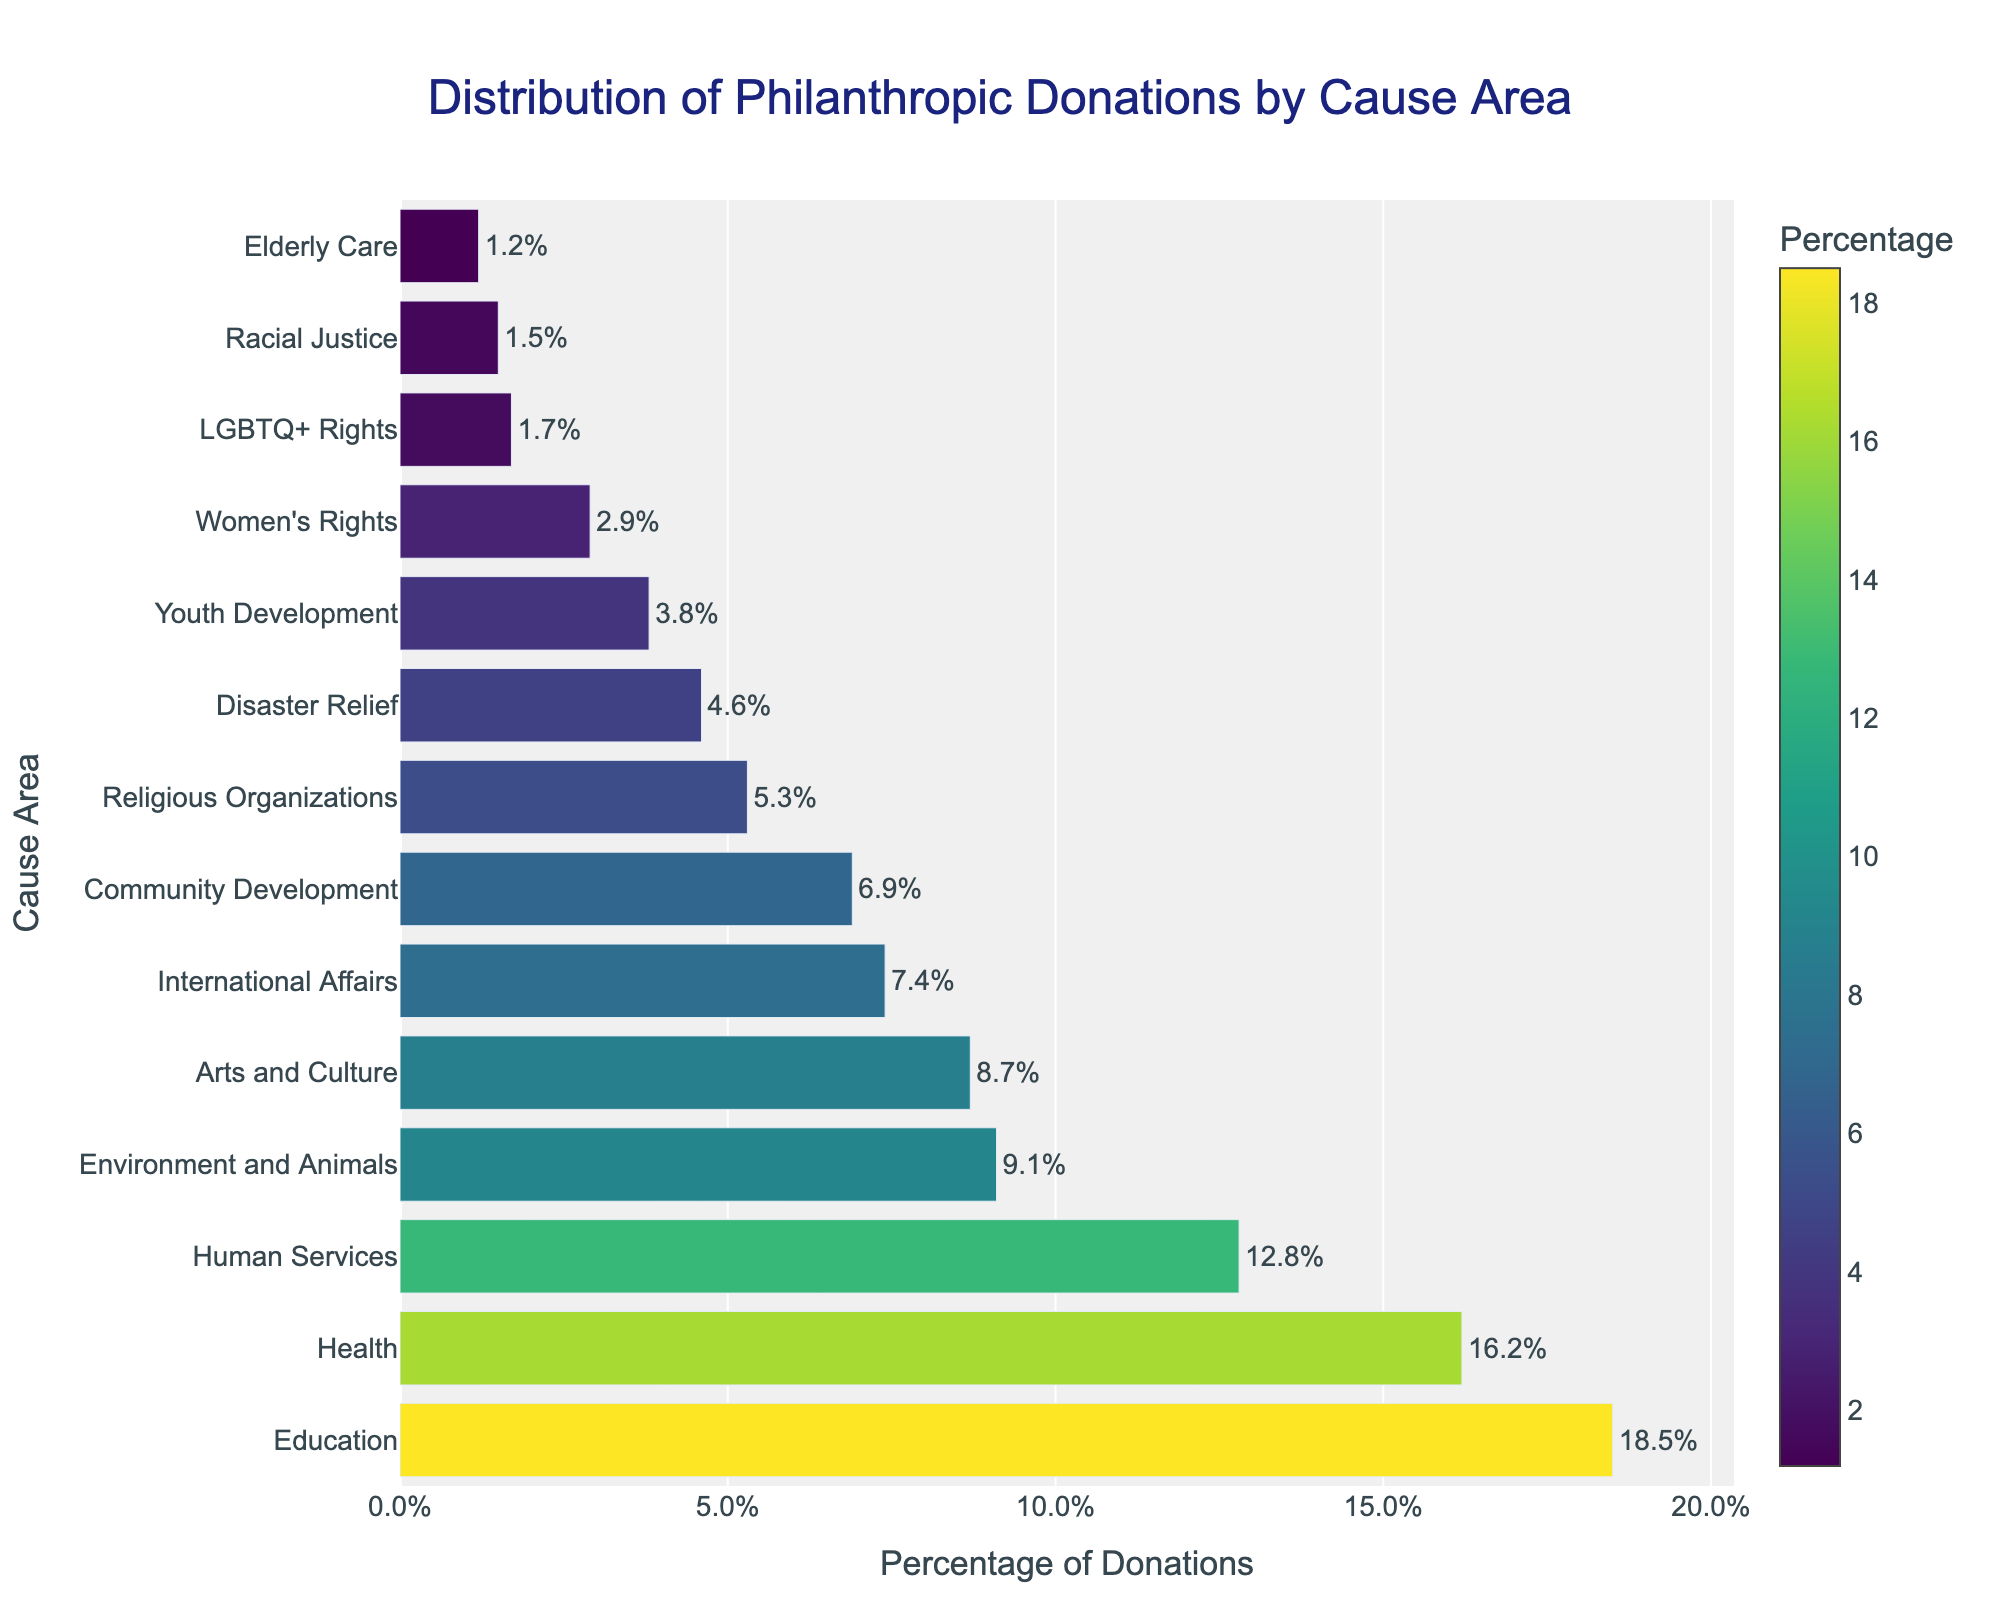What is the most supported cause area according to the distribution of philanthropic donations? The bar chart shows that Education has the highest percentage of donations.
Answer: Education Which cause area received the least amount of donations? The bar chart indicates that Elderly Care has the smallest percentage of donations.
Answer: Elderly Care By how much does the percentage of donations for Education exceed those for Health? The percentage for Education is 18.5%, and for Health, it is 16.2%. The difference is 18.5% - 16.2% = 2.3%.
Answer: 2.3% What is the combined percentage of donations for Human Services and Environment and Animals? Human Services has 12.8% and Environment and Animals has 9.1%. The combined percentage is 12.8% + 9.1% = 21.9%.
Answer: 21.9% Which cause areas have a donation percentage greater than 10%? The cause areas above 10% are Education (18.5%), Health (16.2%), and Human Services (12.8%).
Answer: Education, Health, Human Services What is the total percentage of donations going to Youth Development, Women's Rights, and LGBTQ+ Rights? The percentages are Youth Development 3.8%, Women's Rights 2.9%, and LGBTQ+ Rights 1.7%. The total is 3.8% + 2.9% + 1.7% = 8.4%.
Answer: 8.4% Which cause area has a shorter bar, Disaster Relief or Religious Organizations? The bar chart shows that Disaster Relief has a shorter bar at 4.6%, while Religious Organizations are at 5.3%.
Answer: Disaster Relief How much more in percentage terms does Community Development receive compared to Elderly Care? Community Development has 6.9% and Elderly Care has 1.2%, the difference is 6.9% - 1.2% = 5.7%.
Answer: 5.7% What is the average percentage of donations for the cause areas in the bottom five ranks? The bottom five cause areas and their percentages are Youth Development (3.8%), Women's Rights (2.9%), LGBTQ+ Rights (1.7%), Racial Justice (1.5%), and Elderly Care (1.2%). The total is 3.8% + 2.9% + 1.7% + 1.5% + 1.2% = 11.1%. The average is 11.1% / 5 = 2.22%.
Answer: 2.22% If you sum up the percentages of donations for Education, Health, and Arts and Culture, what would the total be? The percentages are Education 18.5%, Health 16.2%, and Arts and Culture 8.7%. The total is 18.5% + 16.2% + 8.7% = 43.4%.
Answer: 43.4% 